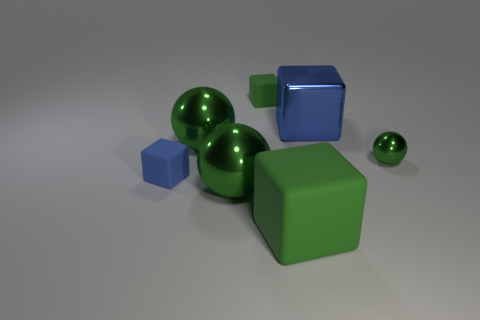Add 2 big metallic cubes. How many objects exist? 9 Subtract all balls. How many objects are left? 4 Add 2 large green shiny balls. How many large green shiny balls are left? 4 Add 4 small green metal things. How many small green metal things exist? 5 Subtract 0 purple cubes. How many objects are left? 7 Subtract all green rubber objects. Subtract all big blue things. How many objects are left? 4 